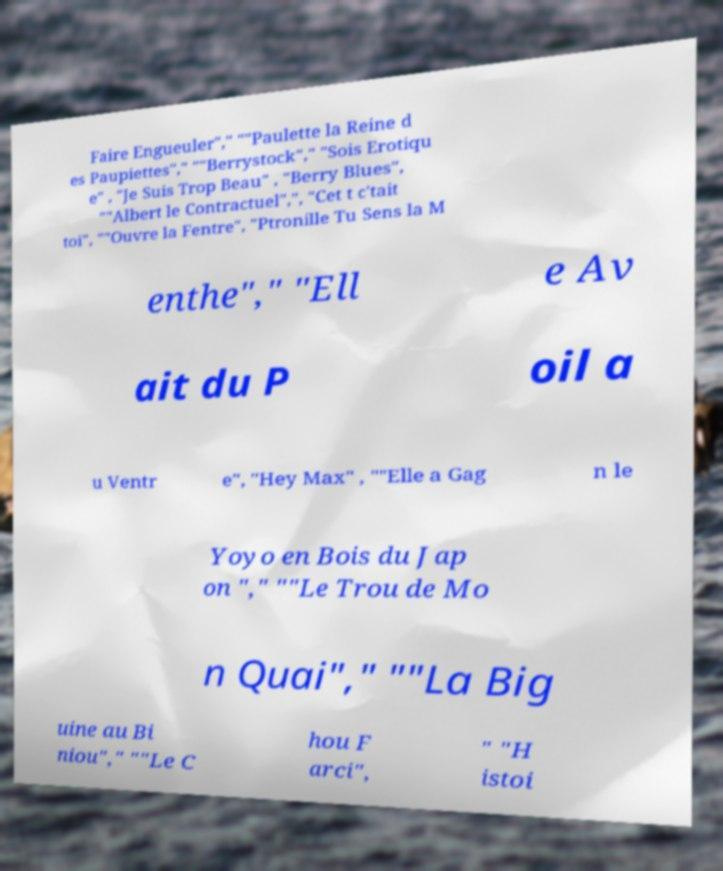Can you accurately transcribe the text from the provided image for me? Faire Engueuler"," ""Paulette la Reine d es Paupiettes"," ""Berrystock"," "Sois Erotiqu e" , "Je Suis Trop Beau" , "Berry Blues", ""Albert le Contractuel",", "Cet t c'tait toi", ""Ouvre la Fentre", "Ptronille Tu Sens la M enthe"," "Ell e Av ait du P oil a u Ventr e", "Hey Max" , ""Elle a Gag n le Yoyo en Bois du Jap on "," ""Le Trou de Mo n Quai"," ""La Big uine au Bi niou"," ""Le C hou F arci", " "H istoi 